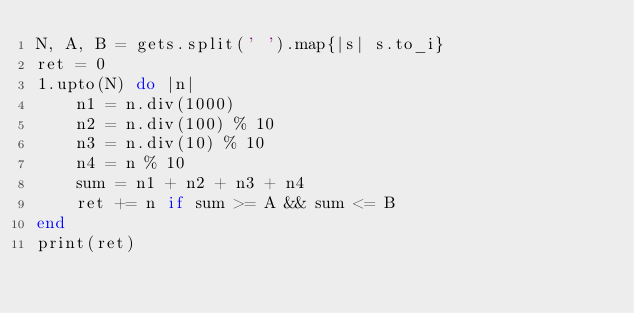Convert code to text. <code><loc_0><loc_0><loc_500><loc_500><_Ruby_>N, A, B = gets.split(' ').map{|s| s.to_i}
ret = 0
1.upto(N) do |n|
    n1 = n.div(1000)
    n2 = n.div(100) % 10
    n3 = n.div(10) % 10
    n4 = n % 10
    sum = n1 + n2 + n3 + n4
    ret += n if sum >= A && sum <= B
end
print(ret)</code> 